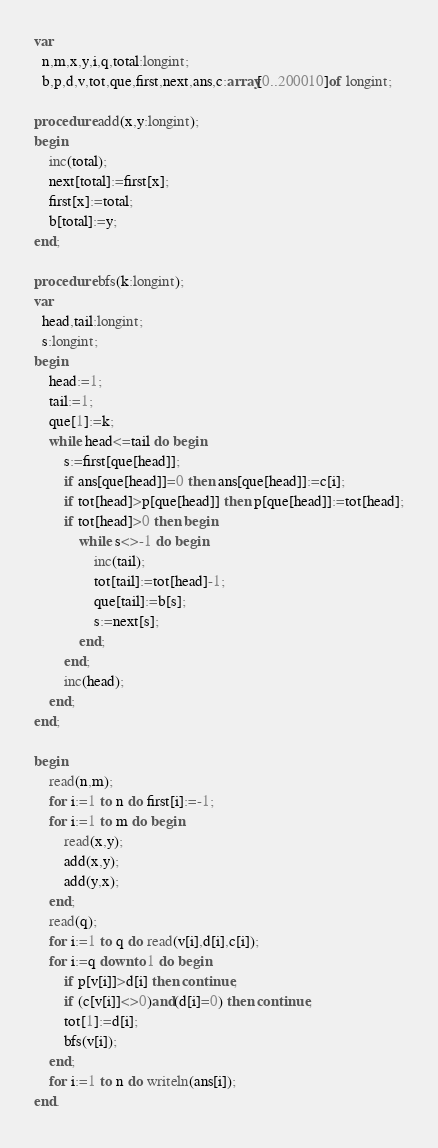Convert code to text. <code><loc_0><loc_0><loc_500><loc_500><_Pascal_>var
  n,m,x,y,i,q,total:longint;
  b,p,d,v,tot,que,first,next,ans,c:array[0..200010]of longint;

procedure add(x,y:longint);
begin
    inc(total);
    next[total]:=first[x];
    first[x]:=total;
    b[total]:=y;
end;

procedure bfs(k:longint);
var
  head,tail:longint;
  s:longint;
begin
    head:=1;
    tail:=1;
    que[1]:=k;
    while head<=tail do begin
        s:=first[que[head]];
        if ans[que[head]]=0 then ans[que[head]]:=c[i];
        if tot[head]>p[que[head]] then p[que[head]]:=tot[head];
        if tot[head]>0 then begin
            while s<>-1 do begin
                inc(tail);
                tot[tail]:=tot[head]-1;
                que[tail]:=b[s];
                s:=next[s];
            end;
        end;
        inc(head);
    end;
end;

begin
    read(n,m);
    for i:=1 to n do first[i]:=-1;
    for i:=1 to m do begin
        read(x,y);
        add(x,y);
        add(y,x);
    end;
    read(q);
    for i:=1 to q do read(v[i],d[i],c[i]);
    for i:=q downto 1 do begin
        if p[v[i]]>d[i] then continue;
        if (c[v[i]]<>0)and(d[i]=0) then continue;
        tot[1]:=d[i];
        bfs(v[i]);
    end;
    for i:=1 to n do writeln(ans[i]);
end.
</code> 